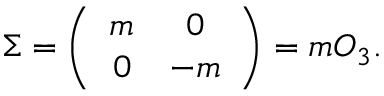<formula> <loc_0><loc_0><loc_500><loc_500>\Sigma = \left ( \begin{array} { c c } { m } & { 0 } \\ { 0 } & { - m } \end{array} \right ) = m O _ { 3 } .</formula> 